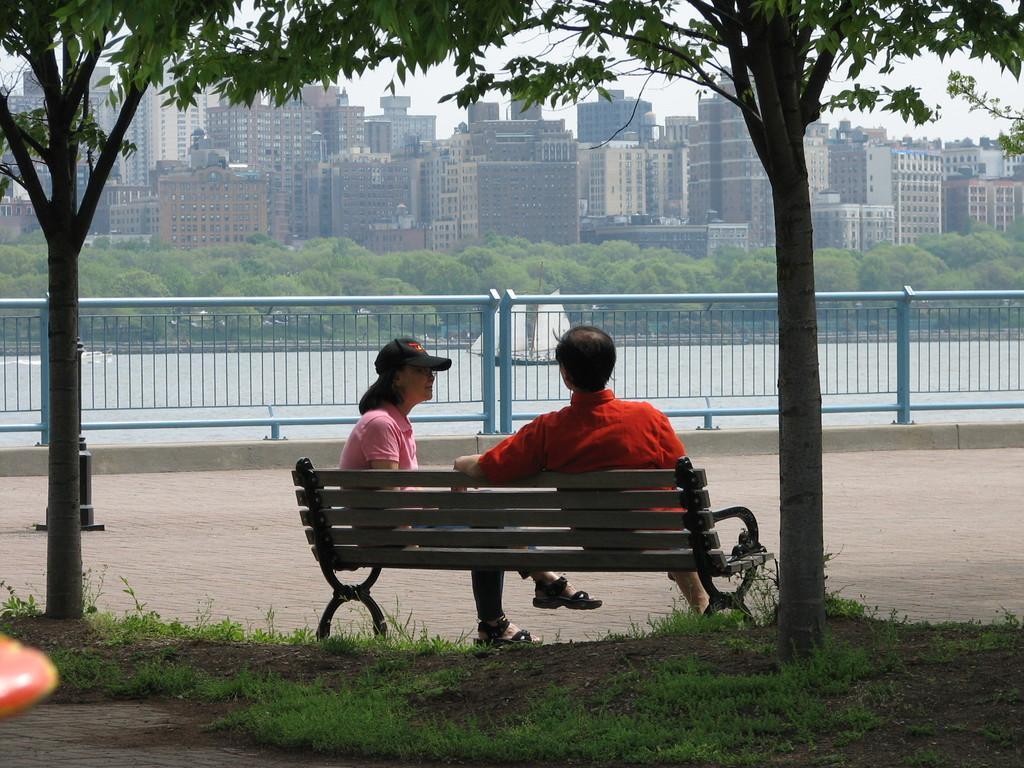Could you give a brief overview of what you see in this image? In this image there are two persons sitting on the bench. Behind them there is a grass on the surface. At front there are buildings, trees and boat in the water. 